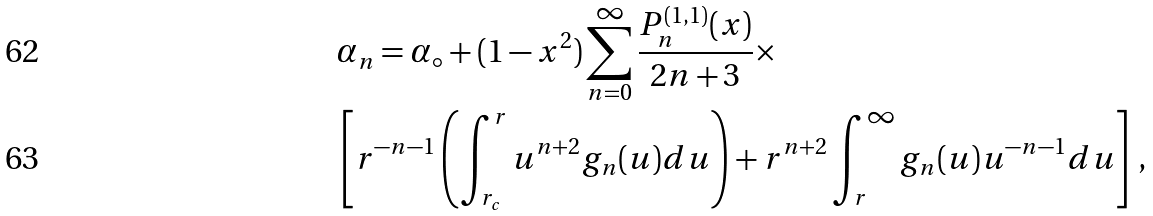Convert formula to latex. <formula><loc_0><loc_0><loc_500><loc_500>& \alpha _ { n } = \alpha _ { \circ } + ( 1 - x ^ { 2 } ) \sum _ { n = 0 } ^ { \infty } \frac { P _ { n } ^ { ( 1 , 1 ) } ( x ) } { 2 n + 3 } \times \\ & \left [ r ^ { - n - 1 } \left ( \int _ { r _ { c } } ^ { r } u ^ { n + 2 } g _ { n } ( u ) d u \right ) + r ^ { n + 2 } \int _ { r } ^ { \infty } g _ { n } ( u ) u ^ { - n - 1 } d u \right ] \, ,</formula> 